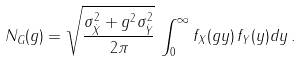Convert formula to latex. <formula><loc_0><loc_0><loc_500><loc_500>N _ { G } ( g ) = \sqrt { \frac { \sigma ^ { 2 } _ { \dot { X } } + g ^ { 2 } \sigma ^ { 2 } _ { \dot { Y } } } { 2 \pi } } \, \int _ { 0 } ^ { \infty } f _ { X } ( g y ) \, f _ { Y } ( y ) d y \, .</formula> 